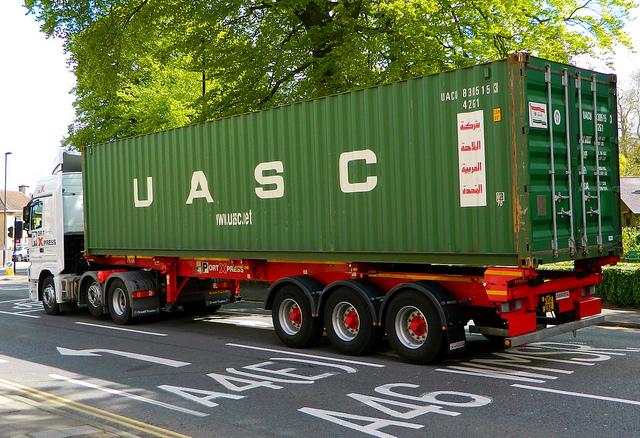What color is the writing?
Short answer required. White. What is displayed on the pavement to the left of the trailer?
Give a very brief answer. A4(e) a46. What letters are on the side of the green trailer?
Quick response, please. Uasc. 